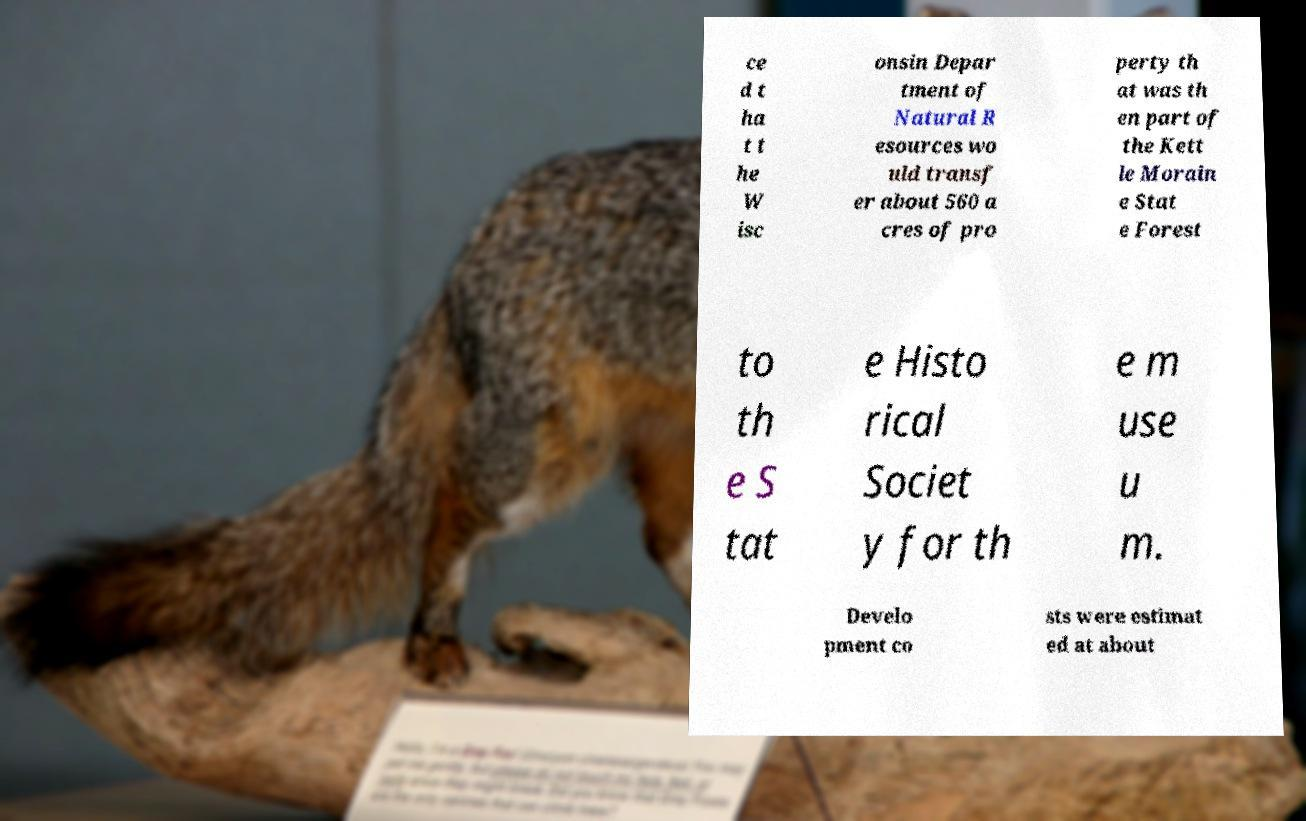Can you read and provide the text displayed in the image?This photo seems to have some interesting text. Can you extract and type it out for me? ce d t ha t t he W isc onsin Depar tment of Natural R esources wo uld transf er about 560 a cres of pro perty th at was th en part of the Kett le Morain e Stat e Forest to th e S tat e Histo rical Societ y for th e m use u m. Develo pment co sts were estimat ed at about 